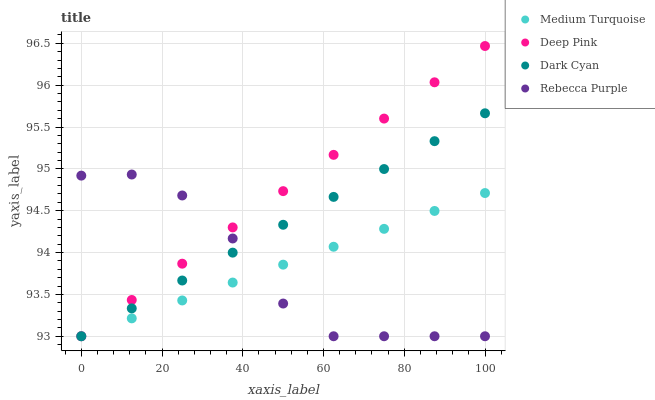Does Rebecca Purple have the minimum area under the curve?
Answer yes or no. Yes. Does Deep Pink have the maximum area under the curve?
Answer yes or no. Yes. Does Deep Pink have the minimum area under the curve?
Answer yes or no. No. Does Rebecca Purple have the maximum area under the curve?
Answer yes or no. No. Is Dark Cyan the smoothest?
Answer yes or no. Yes. Is Rebecca Purple the roughest?
Answer yes or no. Yes. Is Deep Pink the smoothest?
Answer yes or no. No. Is Deep Pink the roughest?
Answer yes or no. No. Does Dark Cyan have the lowest value?
Answer yes or no. Yes. Does Deep Pink have the highest value?
Answer yes or no. Yes. Does Rebecca Purple have the highest value?
Answer yes or no. No. Does Rebecca Purple intersect Medium Turquoise?
Answer yes or no. Yes. Is Rebecca Purple less than Medium Turquoise?
Answer yes or no. No. Is Rebecca Purple greater than Medium Turquoise?
Answer yes or no. No. 